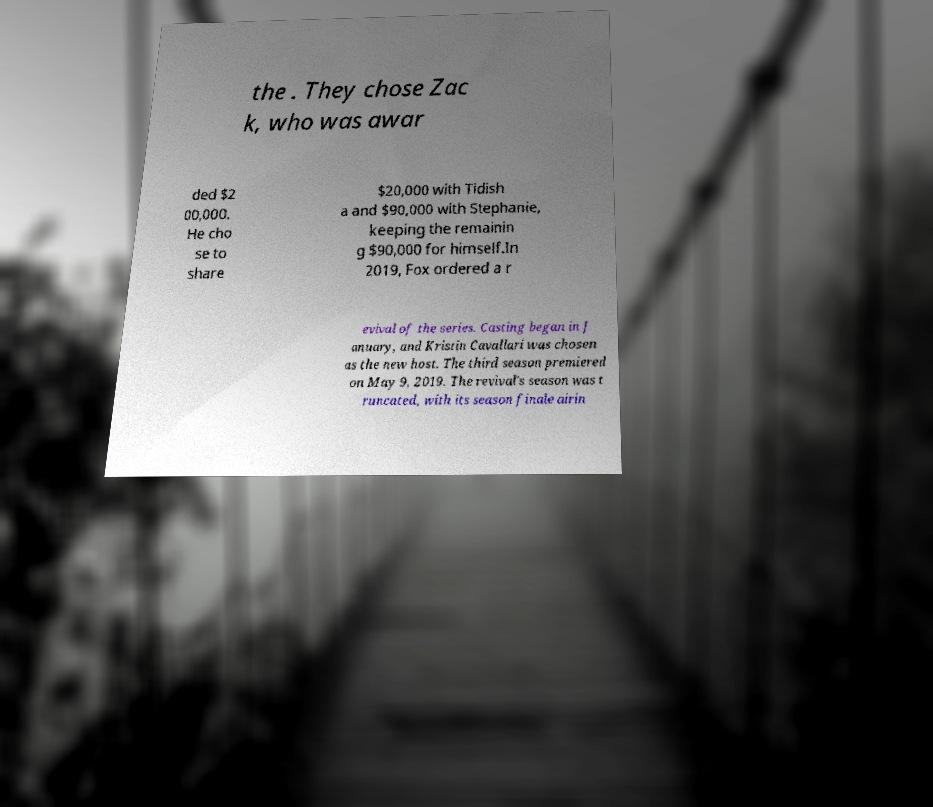For documentation purposes, I need the text within this image transcribed. Could you provide that? the . They chose Zac k, who was awar ded $2 00,000. He cho se to share $20,000 with Tidish a and $90,000 with Stephanie, keeping the remainin g $90,000 for himself.In 2019, Fox ordered a r evival of the series. Casting began in J anuary, and Kristin Cavallari was chosen as the new host. The third season premiered on May 9, 2019. The revival's season was t runcated, with its season finale airin 